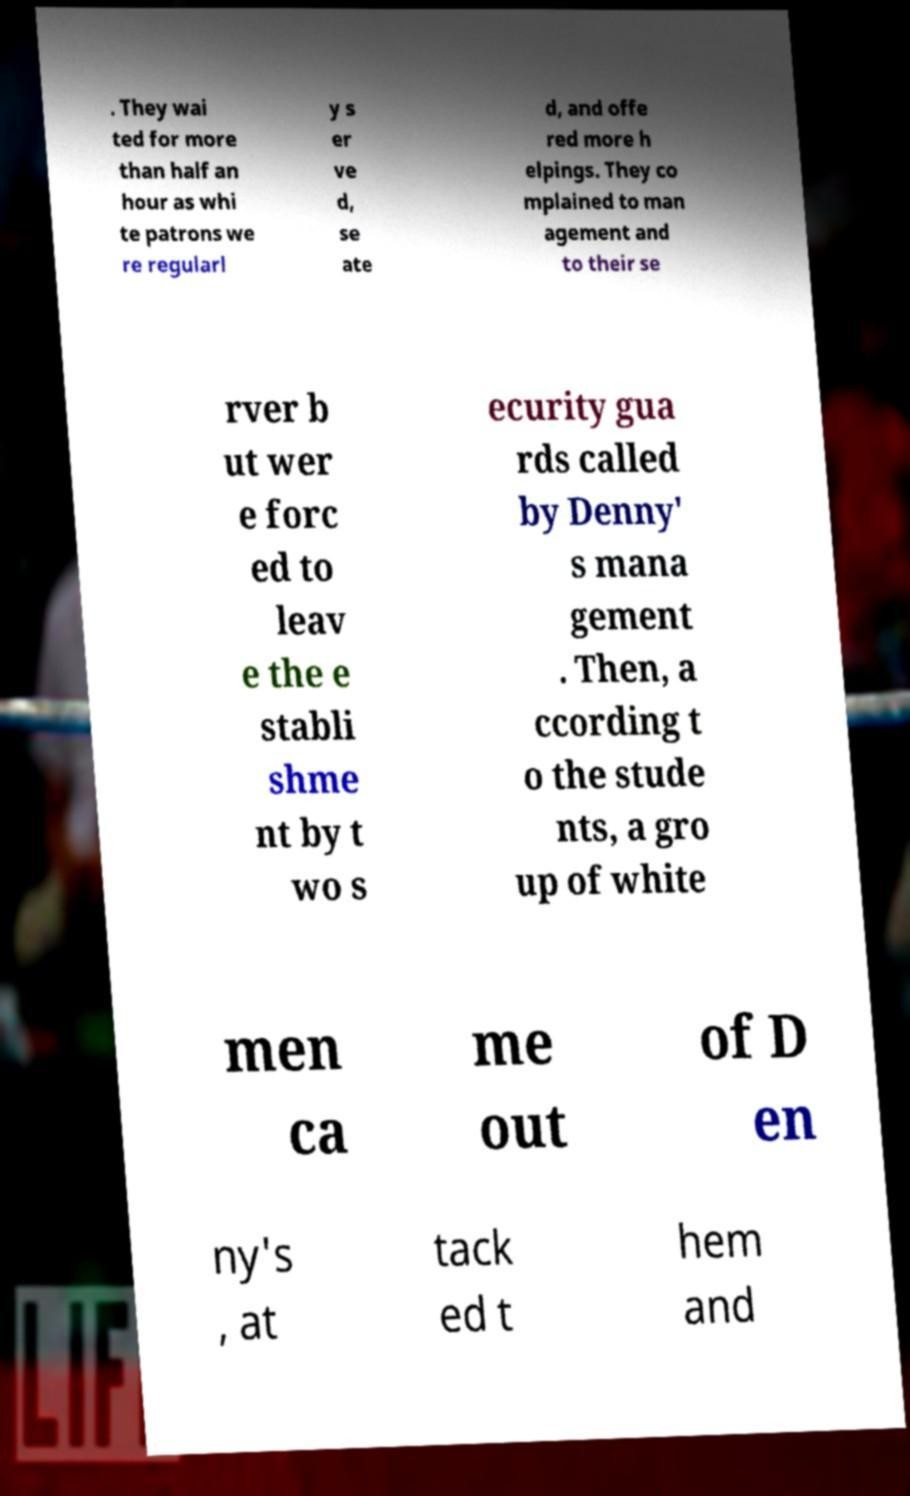Can you read and provide the text displayed in the image?This photo seems to have some interesting text. Can you extract and type it out for me? . They wai ted for more than half an hour as whi te patrons we re regularl y s er ve d, se ate d, and offe red more h elpings. They co mplained to man agement and to their se rver b ut wer e forc ed to leav e the e stabli shme nt by t wo s ecurity gua rds called by Denny' s mana gement . Then, a ccording t o the stude nts, a gro up of white men ca me out of D en ny's , at tack ed t hem and 